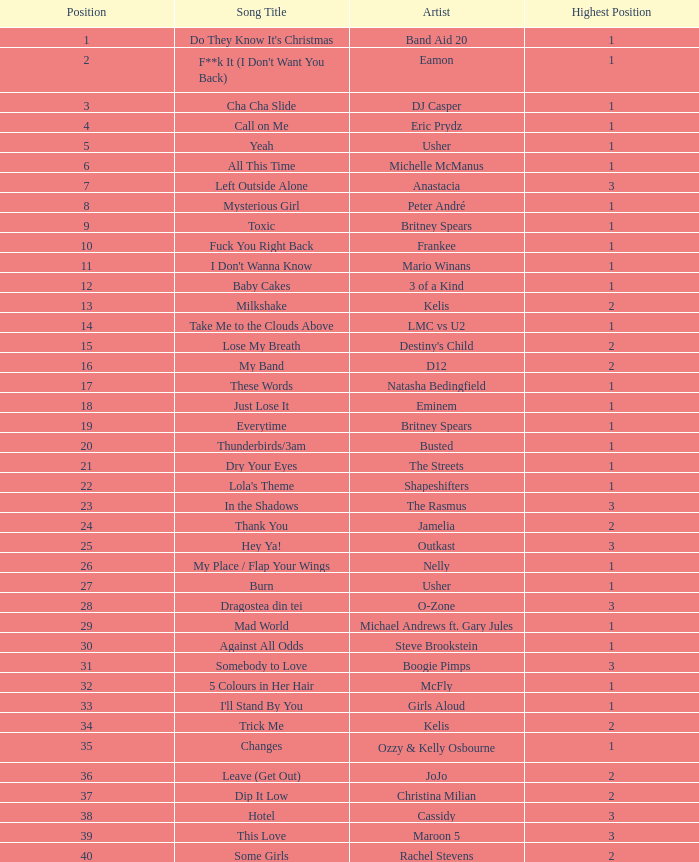What's the maximum sales achieved by a song with a ranking higher than 3? None. 